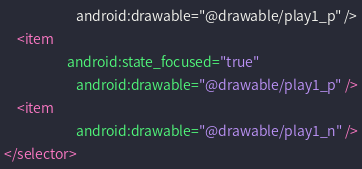Convert code to text. <code><loc_0><loc_0><loc_500><loc_500><_XML_>                       android:drawable="@drawable/play1_p" />
    <item        
                    android:state_focused="true"
                       android:drawable="@drawable/play1_p" />
    <item        
                       android:drawable="@drawable/play1_n" />
</selector></code> 